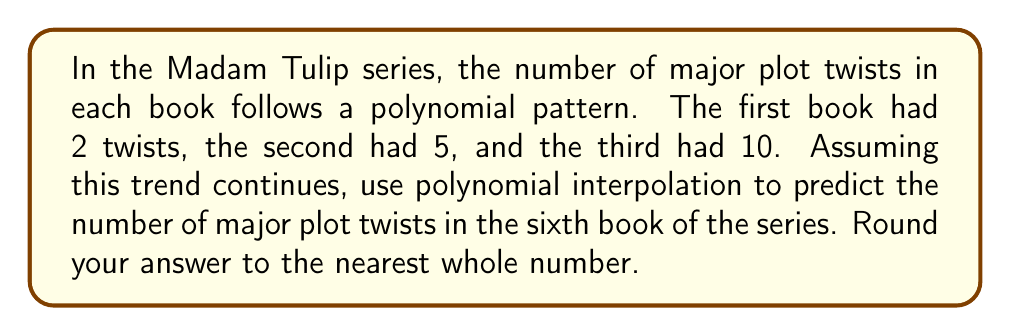Teach me how to tackle this problem. To solve this problem, we'll use polynomial interpolation with the given data points:

$(1, 2)$, $(2, 5)$, $(3, 10)$

We'll use a second-degree polynomial of the form $f(x) = ax^2 + bx + c$, where $x$ represents the book number and $f(x)$ represents the number of plot twists.

Step 1: Set up a system of equations using the given points:
$$\begin{align}
a(1)^2 + b(1) + c &= 2 \\
a(2)^2 + b(2) + c &= 5 \\
a(3)^2 + b(3) + c &= 10
\end{align}$$

Step 2: Simplify the equations:
$$\begin{align}
a + b + c &= 2 \\
4a + 2b + c &= 5 \\
9a + 3b + c &= 10
\end{align}$$

Step 3: Solve the system of equations (using substitution or elimination method):
$$\begin{align}
a &= 1 \\
b &= 1 \\
c &= 0
\end{align}$$

Step 4: Form the polynomial function:
$$f(x) = x^2 + x$$

Step 5: Use the function to predict the number of plot twists in the sixth book:
$$f(6) = 6^2 + 6 = 36 + 6 = 42$$

Therefore, the predicted number of major plot twists in the sixth book is 42.
Answer: 42 major plot twists 